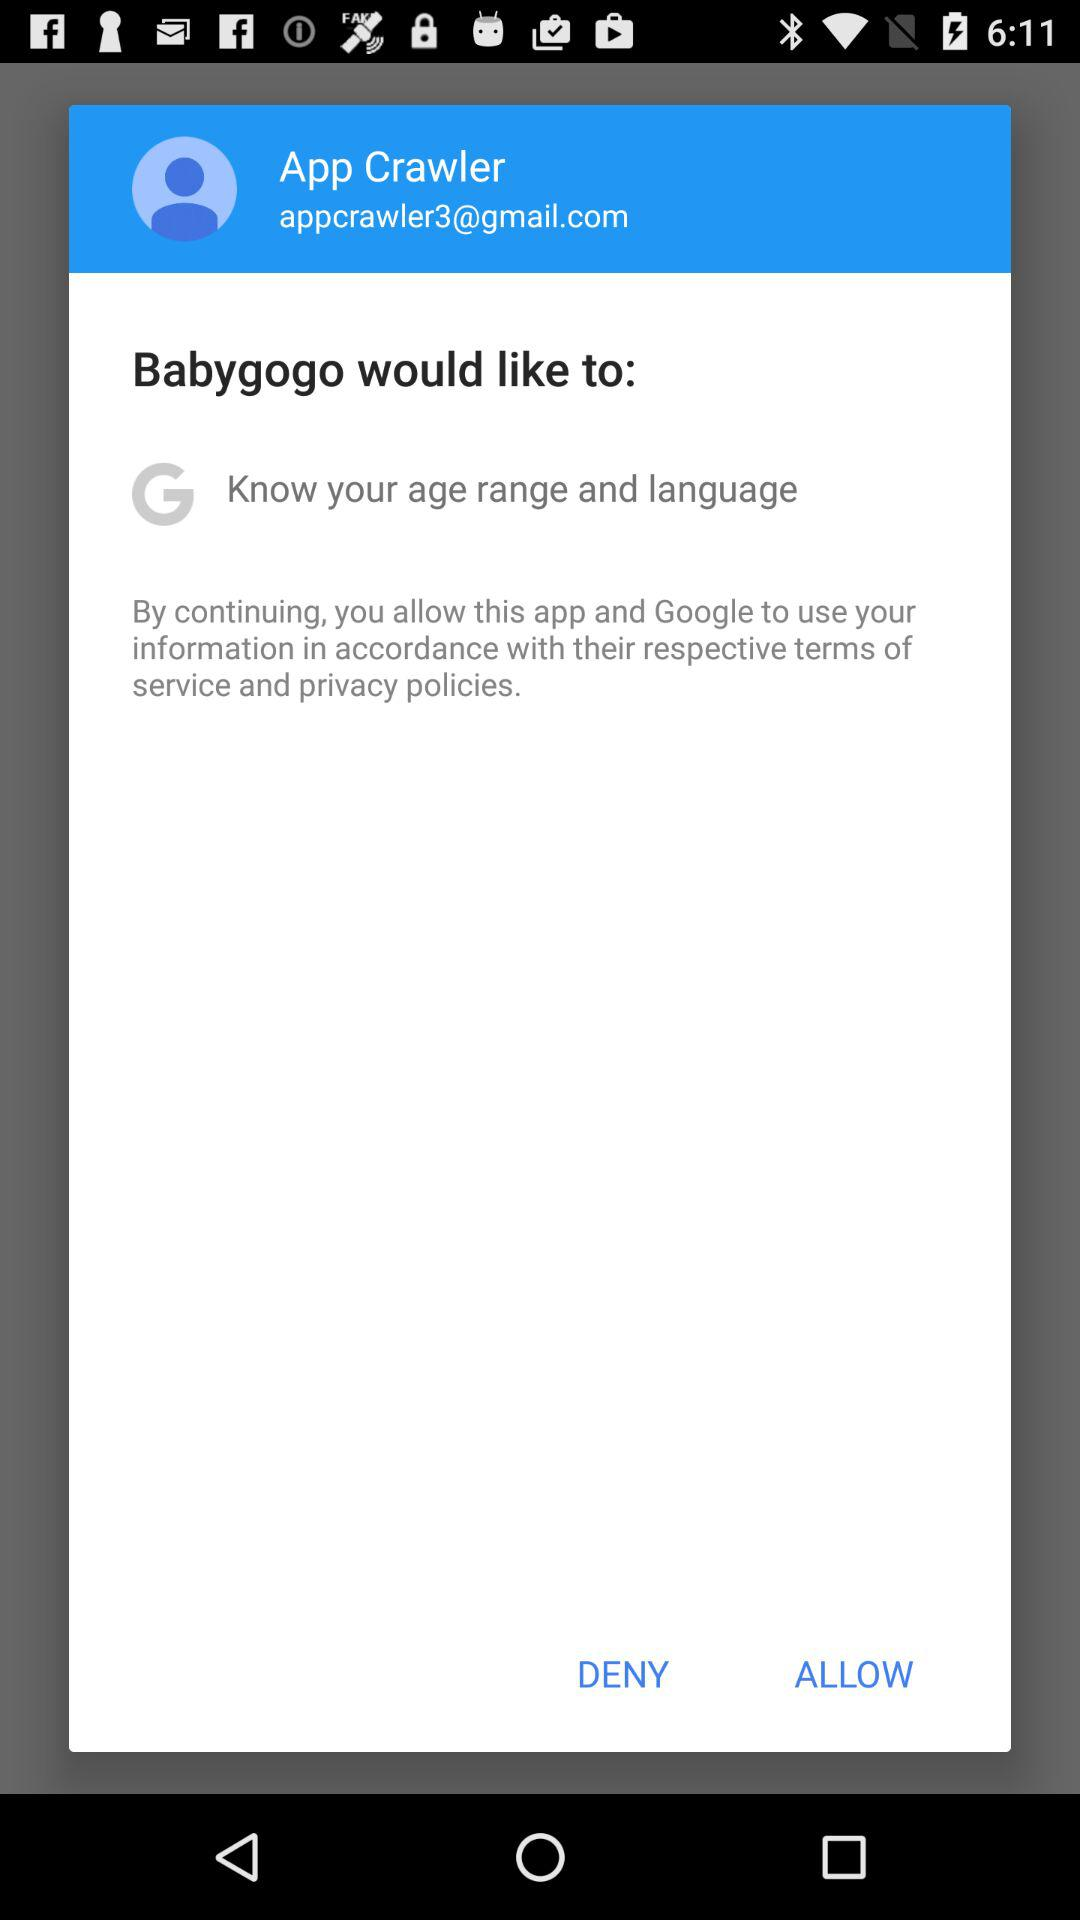What is the user ID of App Crawler? The user ID is appcrawler3@gmail.com. 